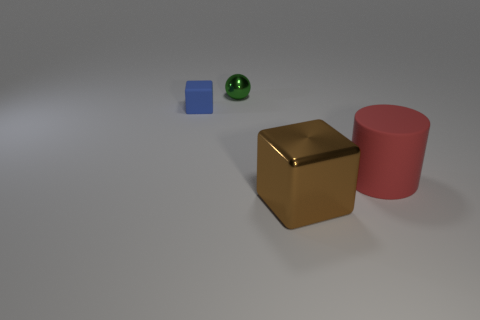The tiny cube is what color?
Offer a terse response. Blue. What number of objects are large balls or green metal balls?
Provide a short and direct response. 1. There is a ball that is the same size as the blue cube; what is it made of?
Provide a succinct answer. Metal. What size is the matte object that is to the right of the big brown object?
Offer a terse response. Large. What is the tiny ball made of?
Your answer should be very brief. Metal. How many things are shiny things that are behind the large red object or metallic objects that are in front of the red matte object?
Give a very brief answer. 2. How many other objects are there of the same color as the small block?
Your response must be concise. 0. Do the tiny matte thing and the shiny thing that is in front of the tiny green metallic object have the same shape?
Your answer should be compact. Yes. Are there fewer big cylinders to the left of the large brown metal block than tiny metal spheres that are to the right of the blue block?
Make the answer very short. Yes. There is another thing that is the same shape as the blue thing; what is its material?
Your answer should be compact. Metal. 